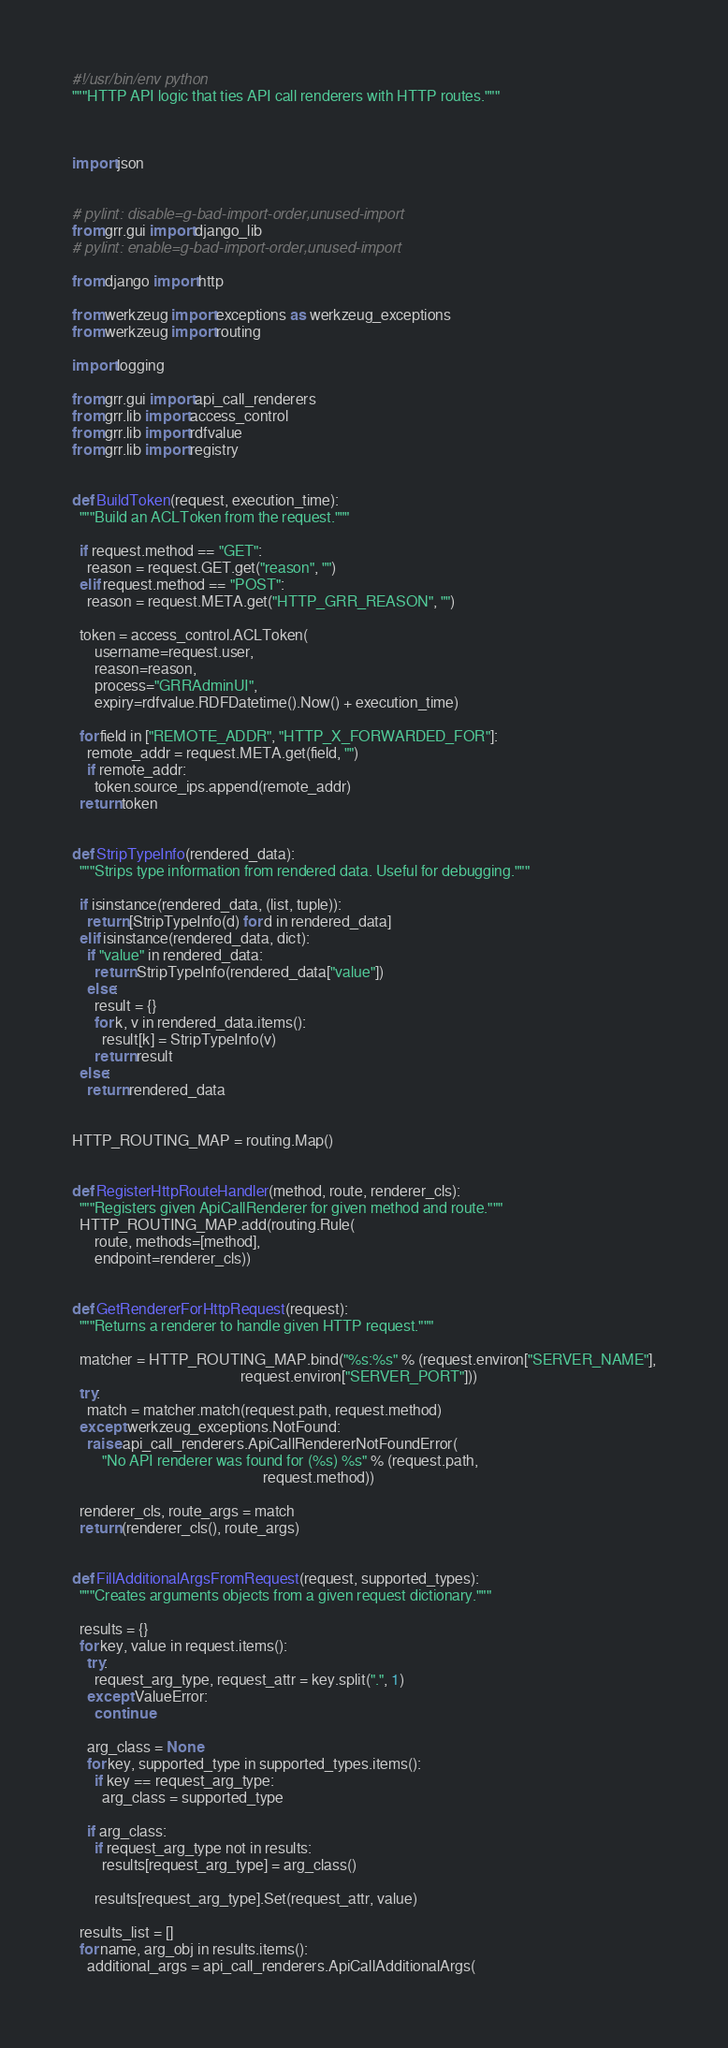Convert code to text. <code><loc_0><loc_0><loc_500><loc_500><_Python_>#!/usr/bin/env python
"""HTTP API logic that ties API call renderers with HTTP routes."""



import json


# pylint: disable=g-bad-import-order,unused-import
from grr.gui import django_lib
# pylint: enable=g-bad-import-order,unused-import

from django import http

from werkzeug import exceptions as werkzeug_exceptions
from werkzeug import routing

import logging

from grr.gui import api_call_renderers
from grr.lib import access_control
from grr.lib import rdfvalue
from grr.lib import registry


def BuildToken(request, execution_time):
  """Build an ACLToken from the request."""

  if request.method == "GET":
    reason = request.GET.get("reason", "")
  elif request.method == "POST":
    reason = request.META.get("HTTP_GRR_REASON", "")

  token = access_control.ACLToken(
      username=request.user,
      reason=reason,
      process="GRRAdminUI",
      expiry=rdfvalue.RDFDatetime().Now() + execution_time)

  for field in ["REMOTE_ADDR", "HTTP_X_FORWARDED_FOR"]:
    remote_addr = request.META.get(field, "")
    if remote_addr:
      token.source_ips.append(remote_addr)
  return token


def StripTypeInfo(rendered_data):
  """Strips type information from rendered data. Useful for debugging."""

  if isinstance(rendered_data, (list, tuple)):
    return [StripTypeInfo(d) for d in rendered_data]
  elif isinstance(rendered_data, dict):
    if "value" in rendered_data:
      return StripTypeInfo(rendered_data["value"])
    else:
      result = {}
      for k, v in rendered_data.items():
        result[k] = StripTypeInfo(v)
      return result
  else:
    return rendered_data


HTTP_ROUTING_MAP = routing.Map()


def RegisterHttpRouteHandler(method, route, renderer_cls):
  """Registers given ApiCallRenderer for given method and route."""
  HTTP_ROUTING_MAP.add(routing.Rule(
      route, methods=[method],
      endpoint=renderer_cls))


def GetRendererForHttpRequest(request):
  """Returns a renderer to handle given HTTP request."""

  matcher = HTTP_ROUTING_MAP.bind("%s:%s" % (request.environ["SERVER_NAME"],
                                             request.environ["SERVER_PORT"]))
  try:
    match = matcher.match(request.path, request.method)
  except werkzeug_exceptions.NotFound:
    raise api_call_renderers.ApiCallRendererNotFoundError(
        "No API renderer was found for (%s) %s" % (request.path,
                                                   request.method))

  renderer_cls, route_args = match
  return (renderer_cls(), route_args)


def FillAdditionalArgsFromRequest(request, supported_types):
  """Creates arguments objects from a given request dictionary."""

  results = {}
  for key, value in request.items():
    try:
      request_arg_type, request_attr = key.split(".", 1)
    except ValueError:
      continue

    arg_class = None
    for key, supported_type in supported_types.items():
      if key == request_arg_type:
        arg_class = supported_type

    if arg_class:
      if request_arg_type not in results:
        results[request_arg_type] = arg_class()

      results[request_arg_type].Set(request_attr, value)

  results_list = []
  for name, arg_obj in results.items():
    additional_args = api_call_renderers.ApiCallAdditionalArgs(</code> 